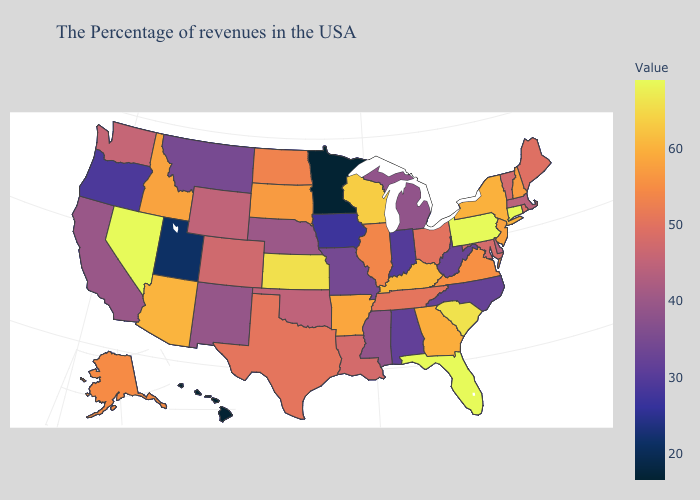Among the states that border Indiana , does Illinois have the highest value?
Short answer required. No. Which states have the lowest value in the USA?
Answer briefly. Minnesota, Hawaii. Does Nevada have the highest value in the USA?
Answer briefly. Yes. Is the legend a continuous bar?
Be succinct. Yes. Does Minnesota have the lowest value in the USA?
Short answer required. Yes. Does Indiana have the lowest value in the MidWest?
Be succinct. No. 